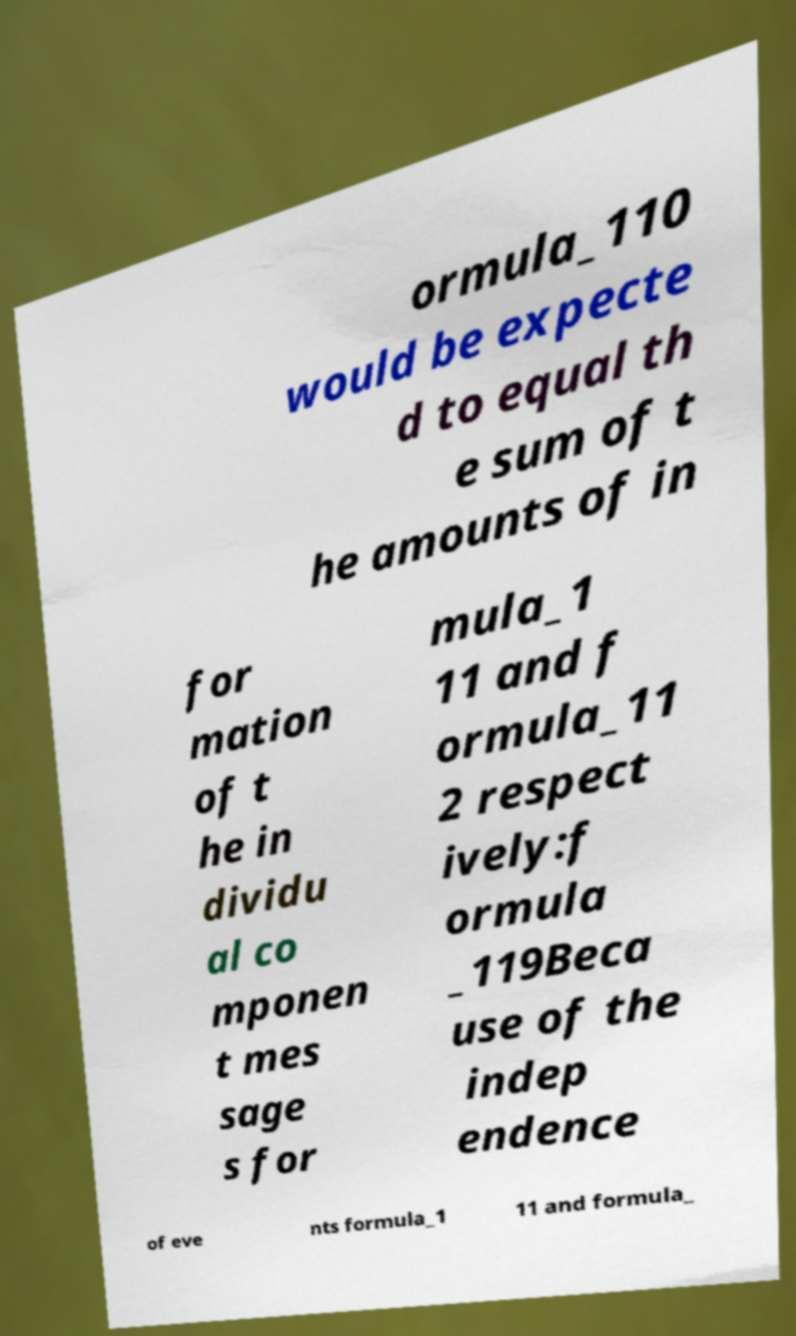What messages or text are displayed in this image? I need them in a readable, typed format. ormula_110 would be expecte d to equal th e sum of t he amounts of in for mation of t he in dividu al co mponen t mes sage s for mula_1 11 and f ormula_11 2 respect ively:f ormula _119Beca use of the indep endence of eve nts formula_1 11 and formula_ 